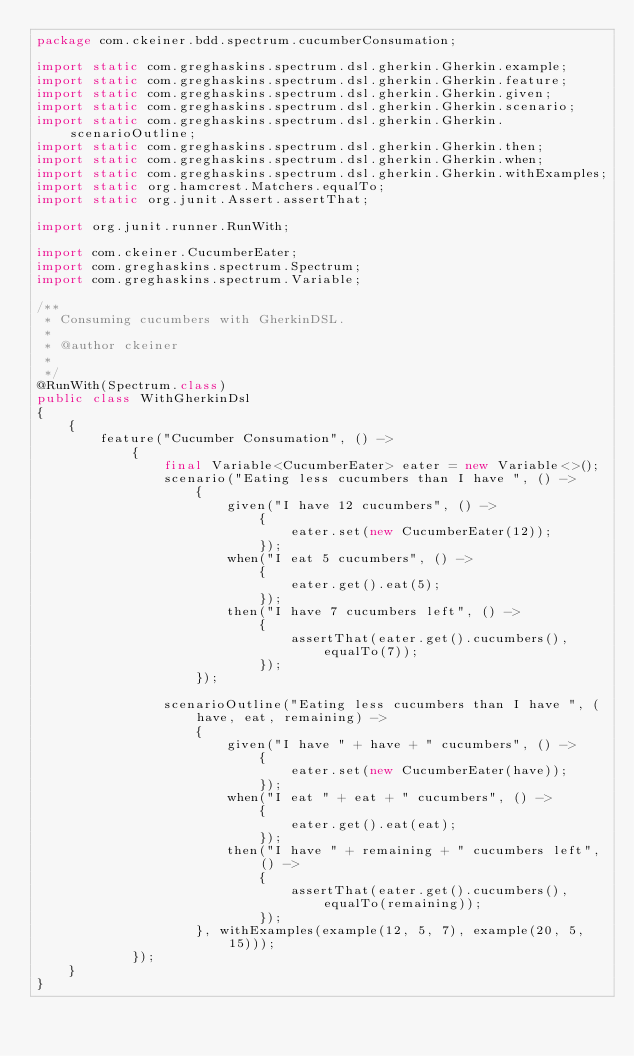Convert code to text. <code><loc_0><loc_0><loc_500><loc_500><_Java_>package com.ckeiner.bdd.spectrum.cucumberConsumation;

import static com.greghaskins.spectrum.dsl.gherkin.Gherkin.example;
import static com.greghaskins.spectrum.dsl.gherkin.Gherkin.feature;
import static com.greghaskins.spectrum.dsl.gherkin.Gherkin.given;
import static com.greghaskins.spectrum.dsl.gherkin.Gherkin.scenario;
import static com.greghaskins.spectrum.dsl.gherkin.Gherkin.scenarioOutline;
import static com.greghaskins.spectrum.dsl.gherkin.Gherkin.then;
import static com.greghaskins.spectrum.dsl.gherkin.Gherkin.when;
import static com.greghaskins.spectrum.dsl.gherkin.Gherkin.withExamples;
import static org.hamcrest.Matchers.equalTo;
import static org.junit.Assert.assertThat;

import org.junit.runner.RunWith;

import com.ckeiner.CucumberEater;
import com.greghaskins.spectrum.Spectrum;
import com.greghaskins.spectrum.Variable;

/**
 * Consuming cucumbers with GherkinDSL.
 * 
 * @author ckeiner
 *
 */
@RunWith(Spectrum.class)
public class WithGherkinDsl
{
    {
        feature("Cucumber Consumation", () ->
            {
                final Variable<CucumberEater> eater = new Variable<>();
                scenario("Eating less cucumbers than I have ", () ->
                    {
                        given("I have 12 cucumbers", () ->
                            {
                                eater.set(new CucumberEater(12));
                            });
                        when("I eat 5 cucumbers", () ->
                            {
                                eater.get().eat(5);
                            });
                        then("I have 7 cucumbers left", () ->
                            {
                                assertThat(eater.get().cucumbers(), equalTo(7));
                            });
                    });

                scenarioOutline("Eating less cucumbers than I have ", (have, eat, remaining) ->
                    {
                        given("I have " + have + " cucumbers", () ->
                            {
                                eater.set(new CucumberEater(have));
                            });
                        when("I eat " + eat + " cucumbers", () ->
                            {
                                eater.get().eat(eat);
                            });
                        then("I have " + remaining + " cucumbers left", () ->
                            {
                                assertThat(eater.get().cucumbers(), equalTo(remaining));
                            });
                    }, withExamples(example(12, 5, 7), example(20, 5, 15)));
            });
    }
}
</code> 